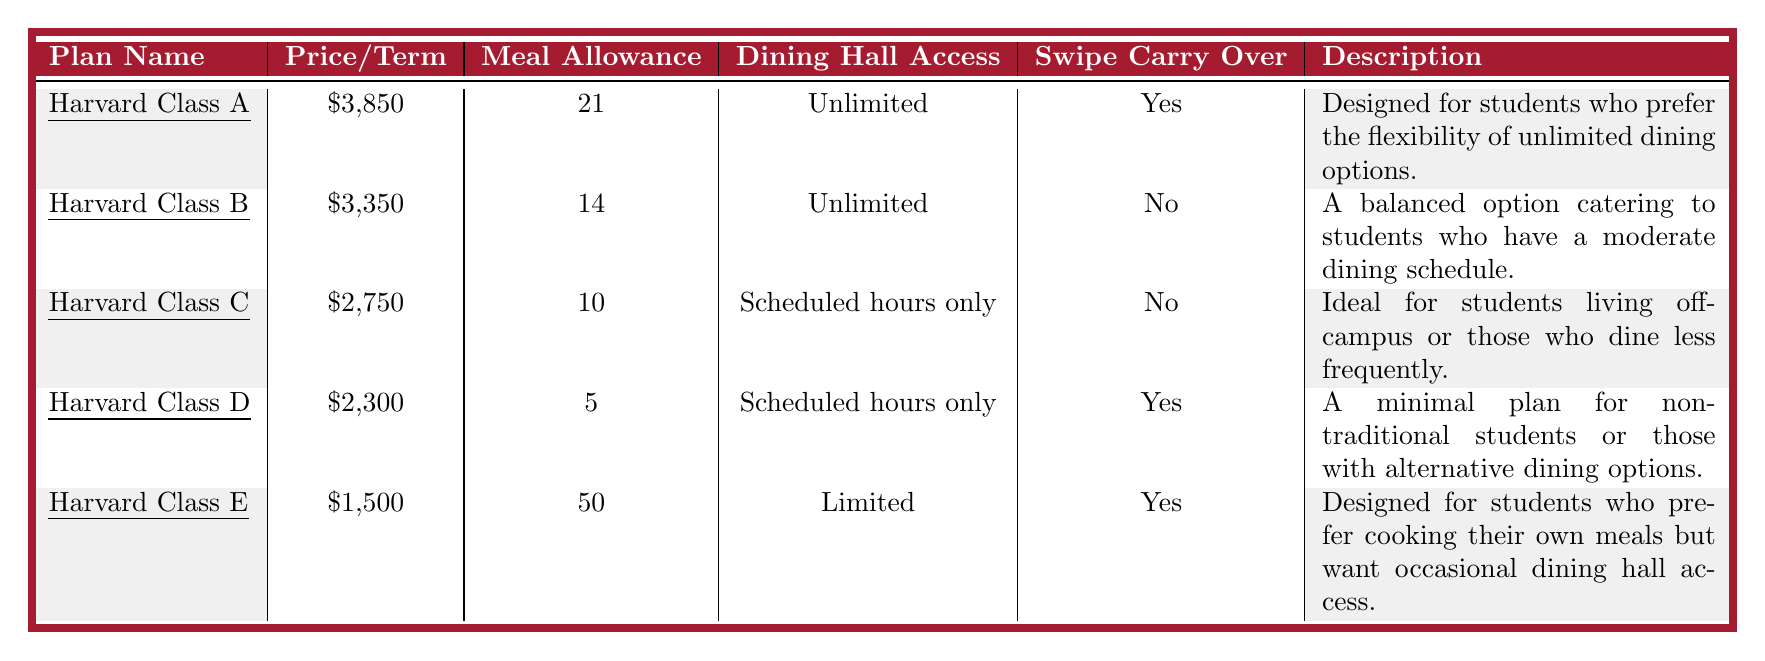What is the most expensive meal plan? The table lists the meal plans along with their prices. The plan with the highest price is the Harvard Class A Meal Plan, priced at $3,850.
Answer: Harvard Class A Meal Plan Which meal plan allows the most meals per week? The meal allowance for each plan indicates meals per week. The Harvard Class A Meal Plan offers 21 meals per week, which is the highest allowance in the table.
Answer: Harvard Class A Meal Plan Is there a meal plan that allows swipe carry over? I checked the "Swipe Carry Over" column for each meal plan. The plans that allow swipe carry over are the Harvard Class A, Class D, and Class E Meal Plans.
Answer: Yes How much cheaper is the Harvard Class E Meal Plan compared to the Harvard Class B Meal Plan? The price of the Harvard Class E Meal Plan is $1,500, and Class B is $3,350. The difference is $3,350 - $1,500 = $1,850, so Class E is cheaper by that amount.
Answer: $1,850 What is the price difference between the meal plan with unlimited dining hall access and the one with scheduled hours only? The Harvard Class A and Class B Meal Plans have unlimited access, priced at $3,850 and $3,350, respectively. The Class C and Class D Meal Plans have scheduled access at $2,750 and $2,300. The difference between Class A and Class C is $3,850 - $2,750 = $1,100.
Answer: $1,100 Which meal plan has the least meal allowance and allows swipe carry over? Looking at the meal allowance and swipe carry over columns, the Harvard Class D Meal Plan has the least allowance of 5 meals per week and allows swipe carry over.
Answer: Harvard Class D Meal Plan What percentage of the total price of the Harvard Class A Meal Plan does the Harvard Class E Meal Plan represent? The price of Class A is $3,850 and Class E is $1,500. To find the percentage: ($1,500 / $3,850) * 100 = 39.01%.
Answer: 39.01% Which meal plan description mentions "non-traditional students"? The description for the Harvard Class D Meal Plan specifically mentions that it is a minimal plan for non-traditional students.
Answer: Harvard Class D Meal Plan What is the maximum number of meals per week available in the plans that do not allow swipe carry over? The plans without swipe carry over are Class B (14 meals) and Class C (10 meals). The maximum is the higher one, which is Class B with 14 meals.
Answer: 14 meals How many meal plans have limited dining hall access? The table indicates that the Harvard Class C and Class E Meal Plans both have limited dining hall access. Thus, there are two meal plans with this feature.
Answer: 2 